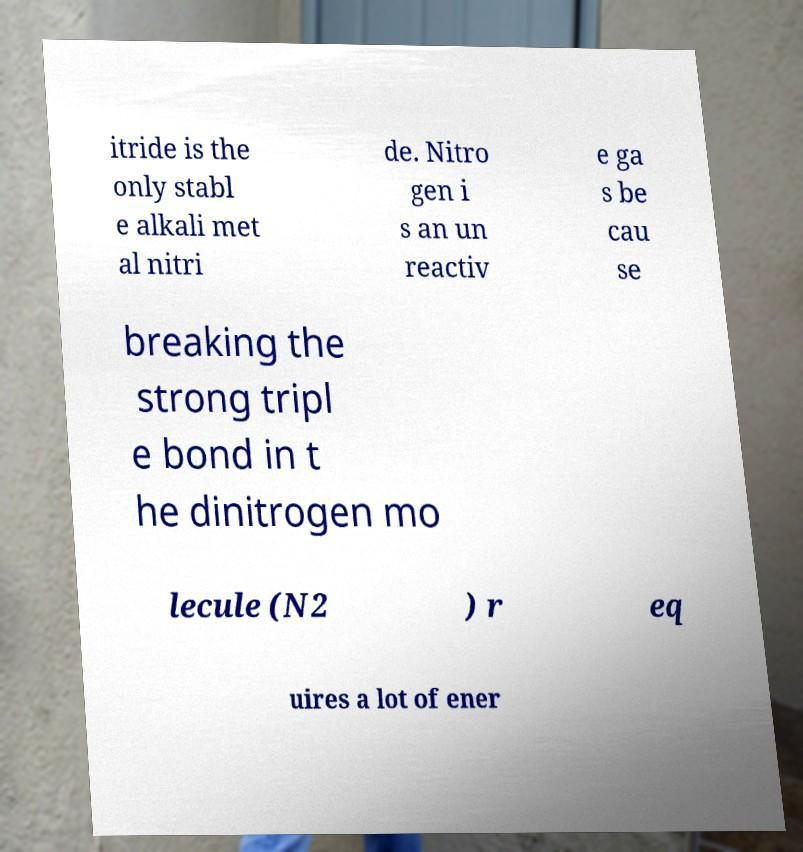Could you extract and type out the text from this image? itride is the only stabl e alkali met al nitri de. Nitro gen i s an un reactiv e ga s be cau se breaking the strong tripl e bond in t he dinitrogen mo lecule (N2 ) r eq uires a lot of ener 